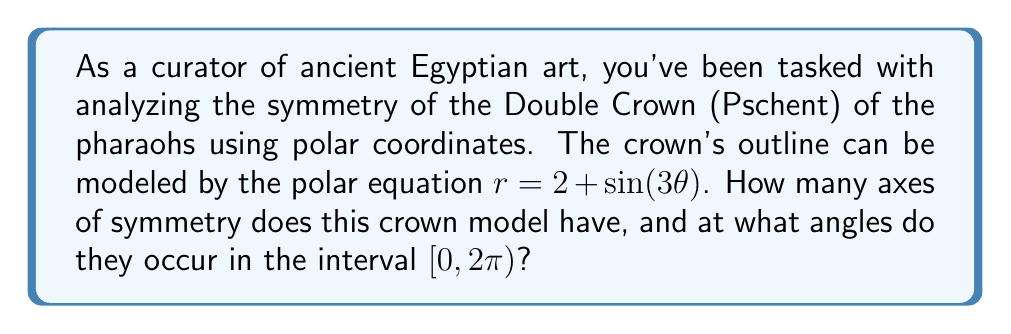Help me with this question. To analyze the symmetry of the pharaoh's crown using the given polar equation, we need to follow these steps:

1) The general form of the equation is $r = 2 + \sin(3\theta)$. This is a rose curve with 3 petals due to the $\sin(3\theta)$ term.

2) For a rose curve $r = a + b\sin(n\theta)$ or $r = a + b\cos(n\theta)$, where $n$ is an odd integer:
   - If $a = 0$, there are $2n$ axes of symmetry.
   - If $a \neq 0$, there are $n$ axes of symmetry.

3) In our case, $a = 2 \neq 0$ and $n = 3$, so we expect 3 axes of symmetry.

4) To find the angles of these axes, we use the formula:
   $\theta_k = \frac{k\pi}{n}$, where $k = 0, 1, 2, ..., n-1$

5) Substituting $n = 3$:
   $\theta_0 = \frac{0\pi}{3} = 0$
   $\theta_1 = \frac{\pi}{3}$
   $\theta_2 = \frac{2\pi}{3}$

6) These angles represent the axes of symmetry in the interval $[0, \pi)$. Due to the periodicity of the sine function, these axes repeat in the interval $[\pi, 2\pi)$.

[asy]
import graph;
size(200);
real r(real t) {return 2+sin(3*t);}
draw(polargraph(r,0,2*pi,operator ..),blue);
draw((0,0)--(3,0),red,Arrow);
draw((0,0)--(cos(pi/3),sin(pi/3))*3,red,Arrow);
draw((0,0)--(cos(2*pi/3),sin(2*pi/3))*3,red,Arrow);
[/asy]

The diagram above shows the polar graph of the crown model with its axes of symmetry marked in red.
Answer: The crown model has 3 axes of symmetry, occurring at angles $0$, $\frac{\pi}{3}$, and $\frac{2\pi}{3}$ in the interval $[0, 2\pi)$. 